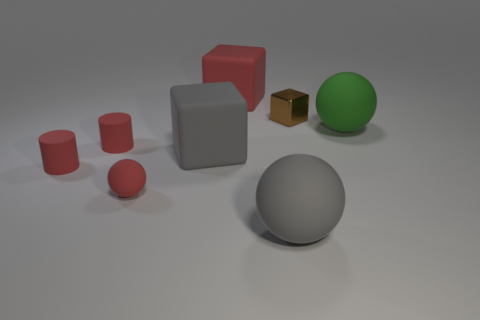Add 2 small spheres. How many objects exist? 10 Subtract all cylinders. How many objects are left? 6 Subtract 1 red blocks. How many objects are left? 7 Subtract all small green objects. Subtract all brown metal cubes. How many objects are left? 7 Add 2 red matte cylinders. How many red matte cylinders are left? 4 Add 6 large red blocks. How many large red blocks exist? 7 